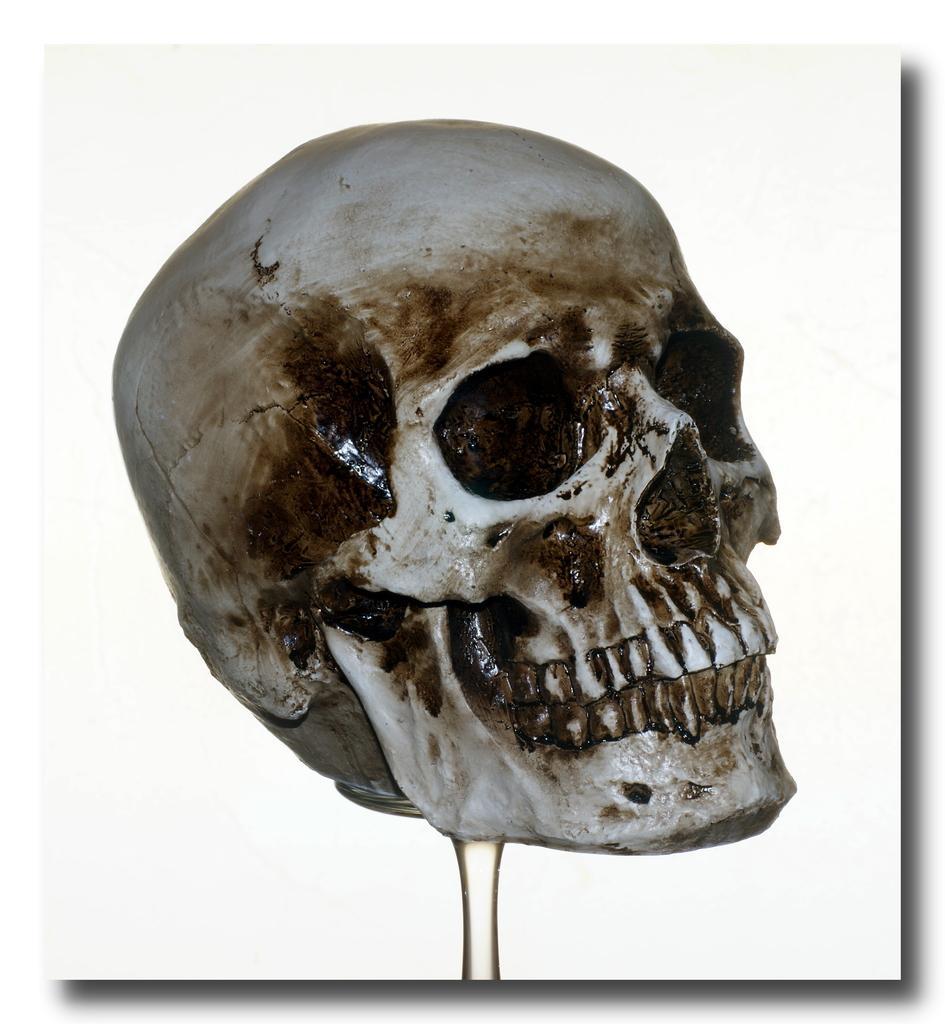Could you give a brief overview of what you see in this image? Here in this picture we can see a photo of a skull present over there. 